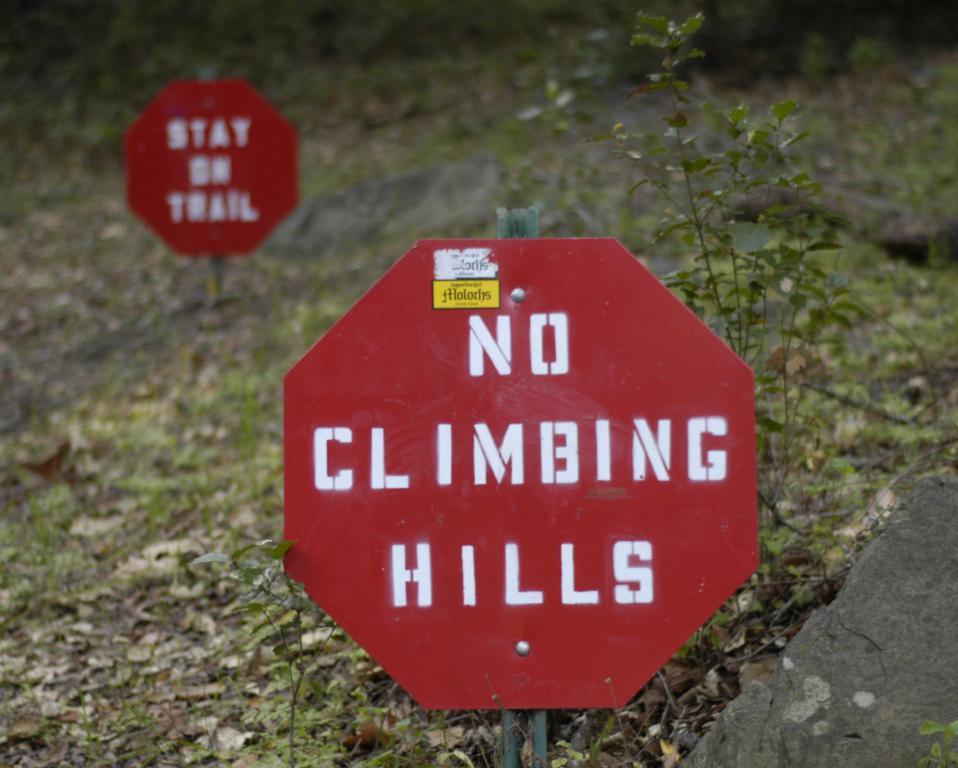Could you give a brief overview of what you see in this image? In this picture we can see name boards on the ground, here we can see a stone, plants, grass. 